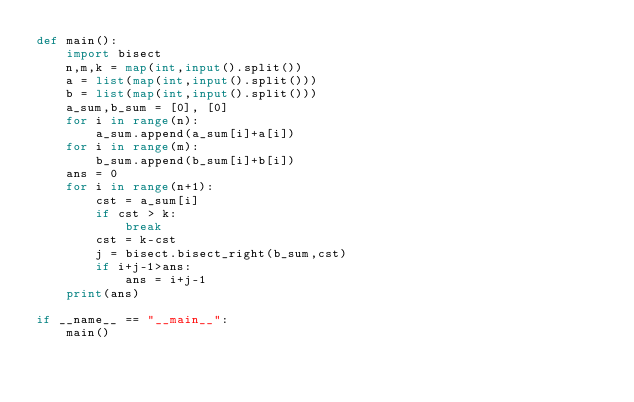<code> <loc_0><loc_0><loc_500><loc_500><_Python_>def main():
    import bisect
    n,m,k = map(int,input().split())
    a = list(map(int,input().split()))
    b = list(map(int,input().split()))
    a_sum,b_sum = [0], [0]
    for i in range(n):
        a_sum.append(a_sum[i]+a[i])
    for i in range(m):
        b_sum.append(b_sum[i]+b[i])
    ans = 0
    for i in range(n+1):
        cst = a_sum[i]
        if cst > k:
            break
        cst = k-cst
        j = bisect.bisect_right(b_sum,cst)
        if i+j-1>ans:
            ans = i+j-1
    print(ans)
    
if __name__ == "__main__":
    main()
</code> 